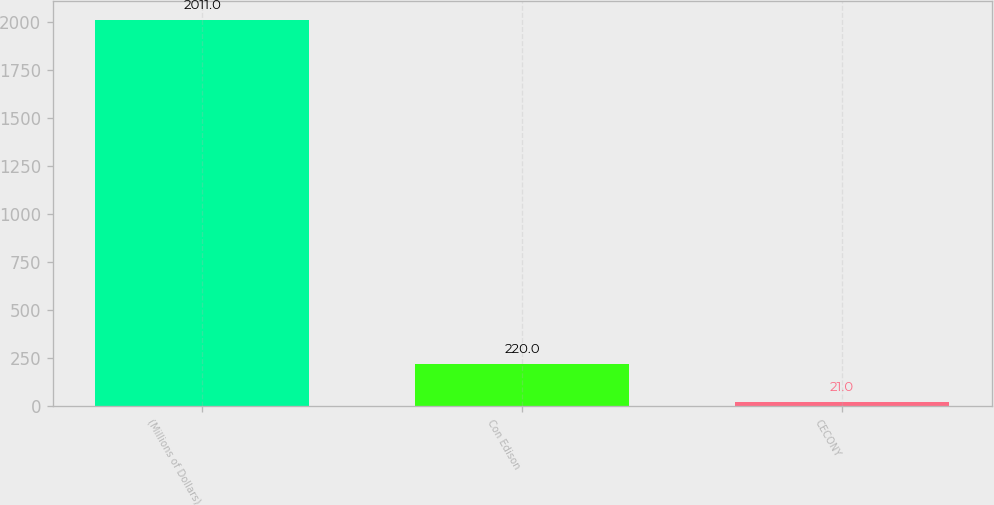Convert chart to OTSL. <chart><loc_0><loc_0><loc_500><loc_500><bar_chart><fcel>(Millions of Dollars)<fcel>Con Edison<fcel>CECONY<nl><fcel>2011<fcel>220<fcel>21<nl></chart> 